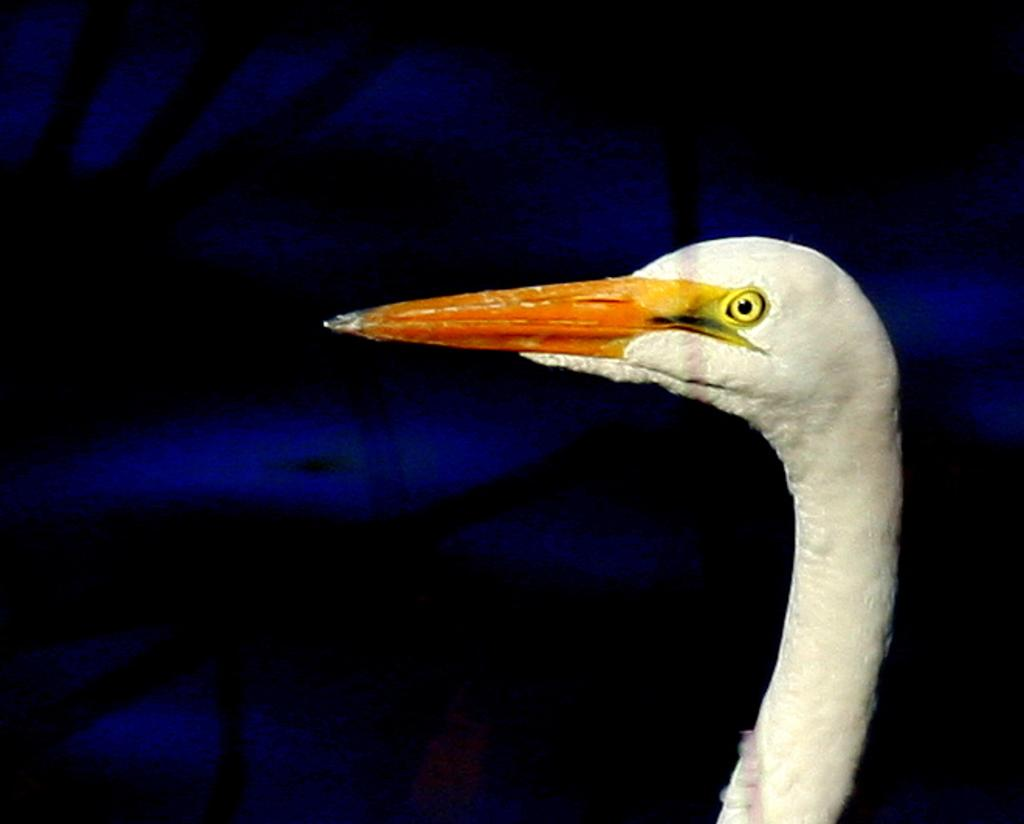What type of animal is present in the image? There is a bird in the image. What type of vegetable is being transported by the trucks in the image? There are no trucks present in the image, and therefore no vegetable transportation can be observed. 